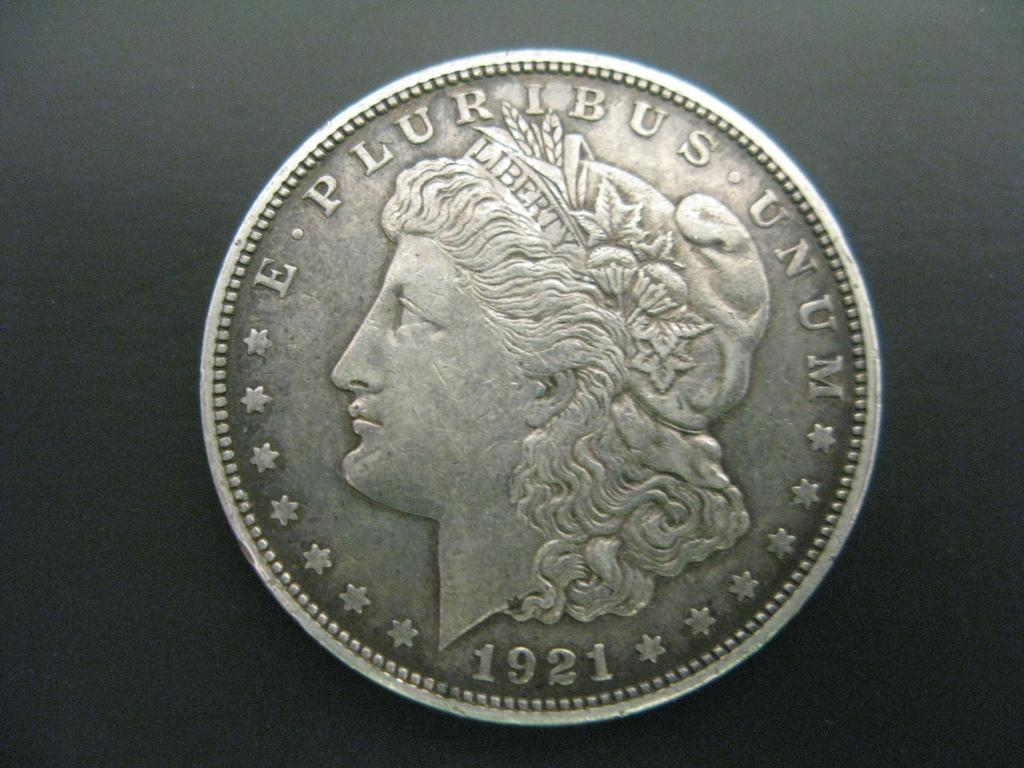Provide a one-sentence caption for the provided image. The old silver coin on the grey background was made in 1921. 